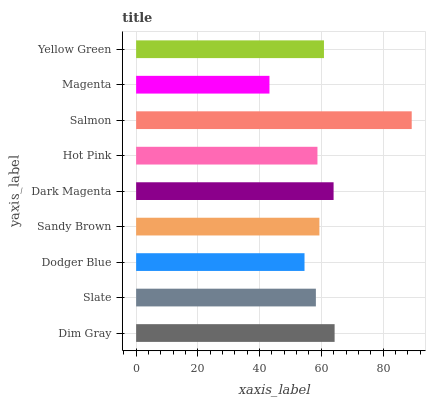Is Magenta the minimum?
Answer yes or no. Yes. Is Salmon the maximum?
Answer yes or no. Yes. Is Slate the minimum?
Answer yes or no. No. Is Slate the maximum?
Answer yes or no. No. Is Dim Gray greater than Slate?
Answer yes or no. Yes. Is Slate less than Dim Gray?
Answer yes or no. Yes. Is Slate greater than Dim Gray?
Answer yes or no. No. Is Dim Gray less than Slate?
Answer yes or no. No. Is Sandy Brown the high median?
Answer yes or no. Yes. Is Sandy Brown the low median?
Answer yes or no. Yes. Is Dim Gray the high median?
Answer yes or no. No. Is Dim Gray the low median?
Answer yes or no. No. 